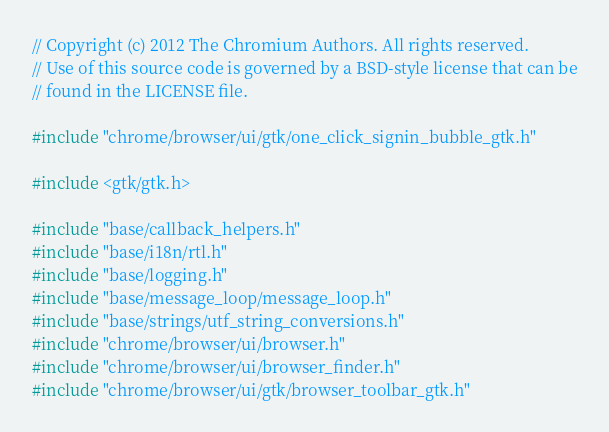Convert code to text. <code><loc_0><loc_0><loc_500><loc_500><_C++_>// Copyright (c) 2012 The Chromium Authors. All rights reserved.
// Use of this source code is governed by a BSD-style license that can be
// found in the LICENSE file.

#include "chrome/browser/ui/gtk/one_click_signin_bubble_gtk.h"

#include <gtk/gtk.h>

#include "base/callback_helpers.h"
#include "base/i18n/rtl.h"
#include "base/logging.h"
#include "base/message_loop/message_loop.h"
#include "base/strings/utf_string_conversions.h"
#include "chrome/browser/ui/browser.h"
#include "chrome/browser/ui/browser_finder.h"
#include "chrome/browser/ui/gtk/browser_toolbar_gtk.h"</code> 